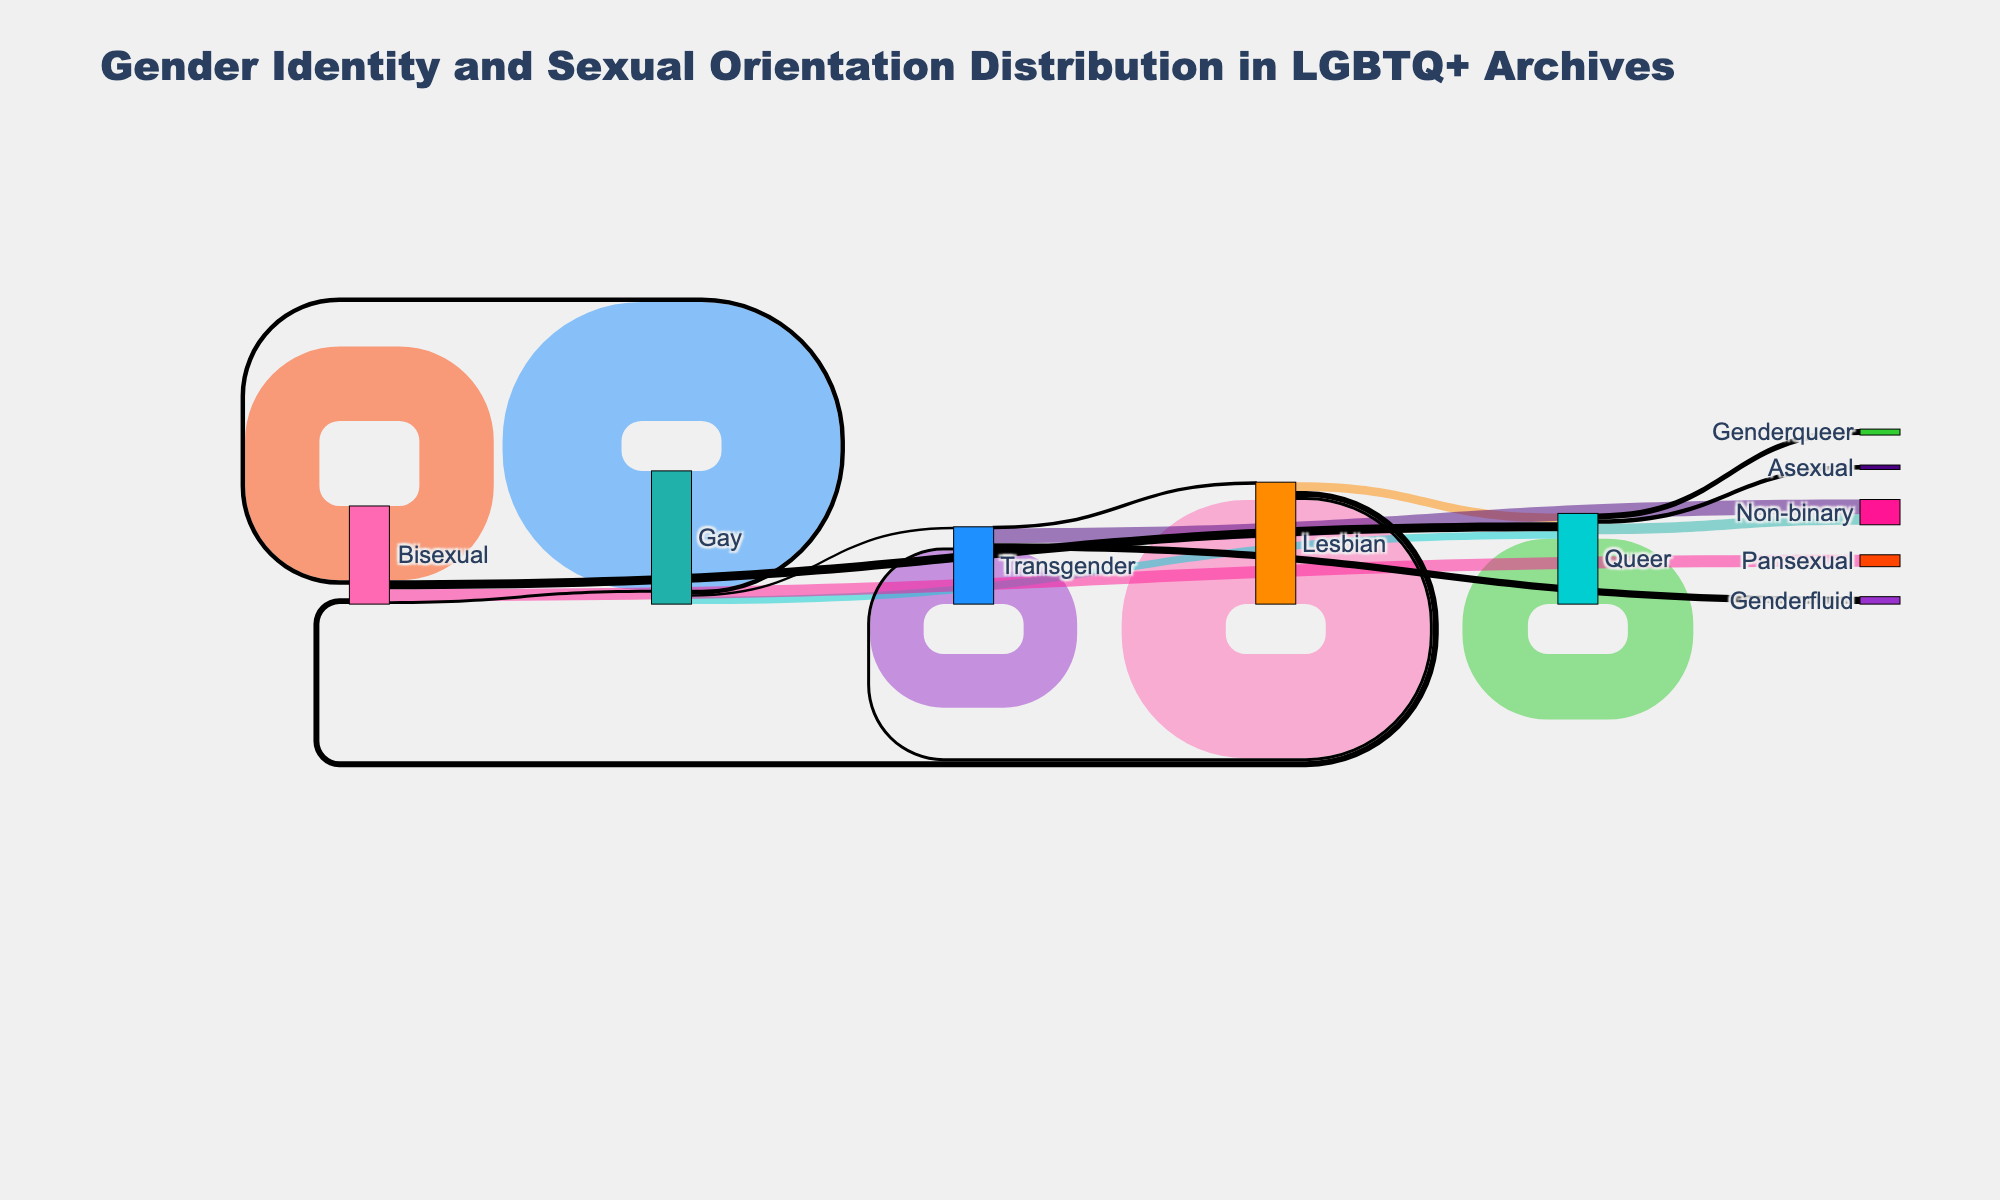What is the most frequent gender identity in the archives? By examining the width of the flows and the labels, the largest flow corresponds to Gay with a value of 400.
Answer: Gay How many individuals transition from Lesbian to Queer? According to the labels and the value from Lesbian to Queer, it’s given as 30.
Answer: 30 Which identity category transitions the most towards Non-binary? Look at the flows leading to Non-binary and compare their values. The highest value flow towards Non-binary is from Transgender with 50.
Answer: Transgender What is the total value for all flows originating from Queer? To calculate this, sum all values originating from Queer: 220 (Queer to Queer) + 35 (Queer to Non-binary) + 15 (Queer to Asexual) + 20 (Queer to Genderqueer) = 290.
Answer: 290 Which identity has the smallest number of individuals who transition to Genderfluid? Identify the flow values ending at Genderfluid. The only flow to Genderfluid is from Transgender with the value of 25.
Answer: Transgender How does the number of individuals transitioning from Bisexual to Pansexual compare to those remaining Bisexual? Compare the values: transitioning to Pansexual is 40, and remaining Bisexual is 250.
Answer: Remain Bisexual What is the total number of individuals recorded in the archives? Sum all the values at their respective sources: 350 (Lesbian) + 400 (Gay) + 250 (Bisexual) + 180 (Transgender) + 220 (Queer) = 1400.
Answer: 1400 What category has the highest number of transitions away? Sum all outgoing transitions for each category and compare: 
Lesbian: 350 (Lesbian) + 30 + 20 + 10 = 60,
Gay: 400 (Gay) + 25 + 15 + 8 = 48,
Bisexual: 250 (Bisexual) + 40 + 10 + 30 = 80,
Transgender: 180 (Transgender) + 50 + 5 + 25 = 80,
Queer: 220 (Queer) + 35 + 15 + 20 = 70.
The highest is both Bisexual and Transgender with outgoing transitions of 80.
Answer: Bisexual and Transgender 